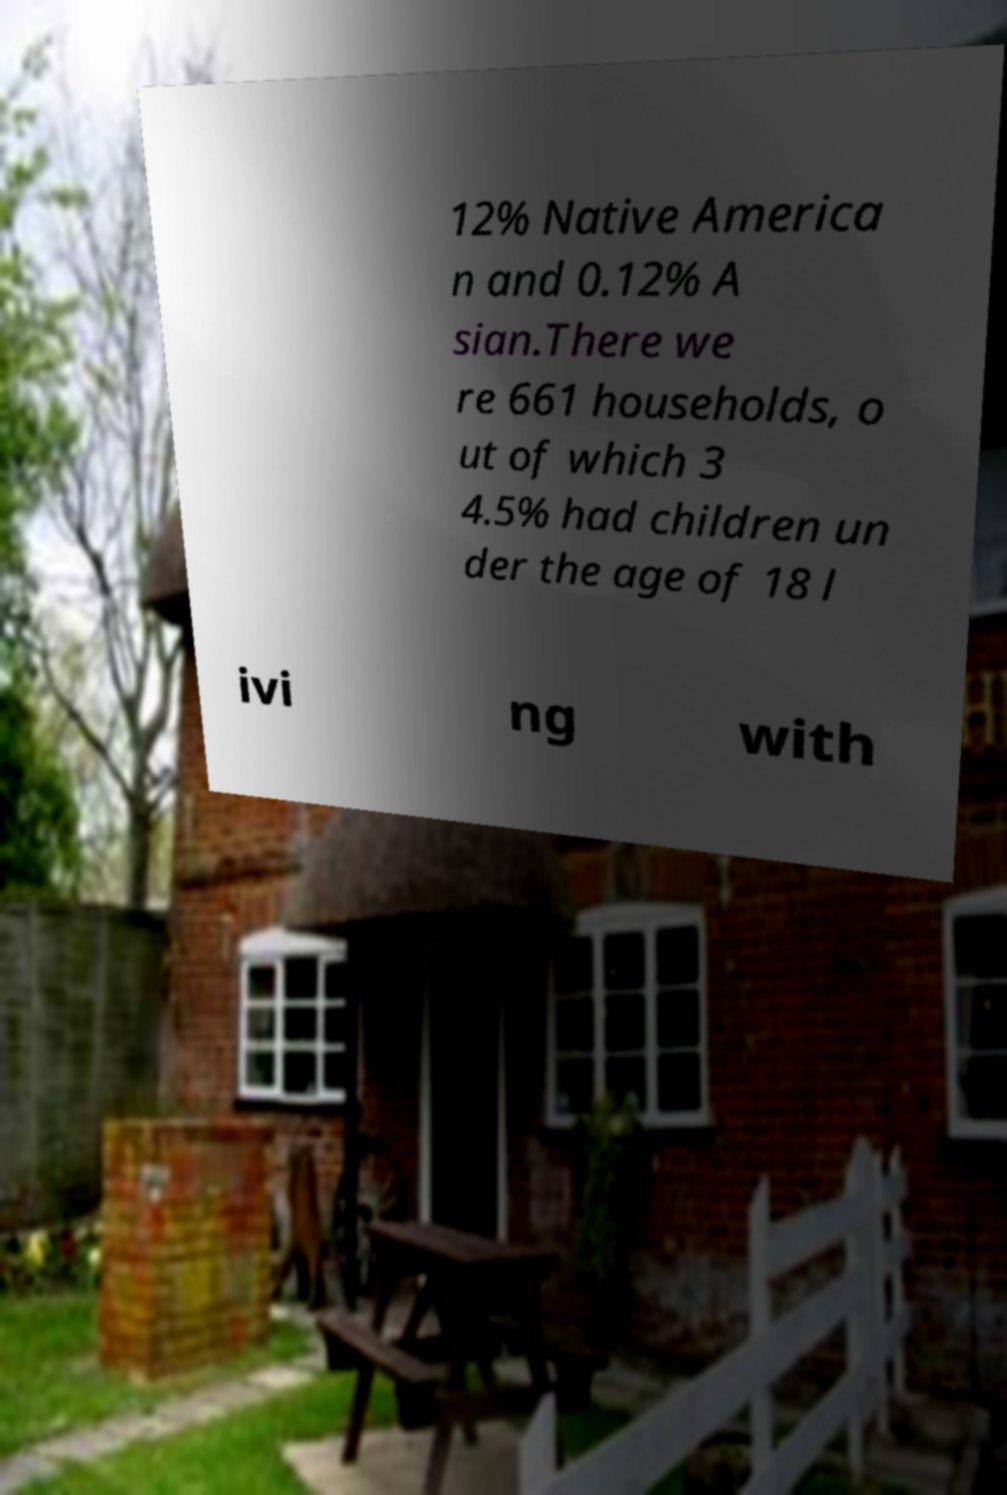Please identify and transcribe the text found in this image. 12% Native America n and 0.12% A sian.There we re 661 households, o ut of which 3 4.5% had children un der the age of 18 l ivi ng with 